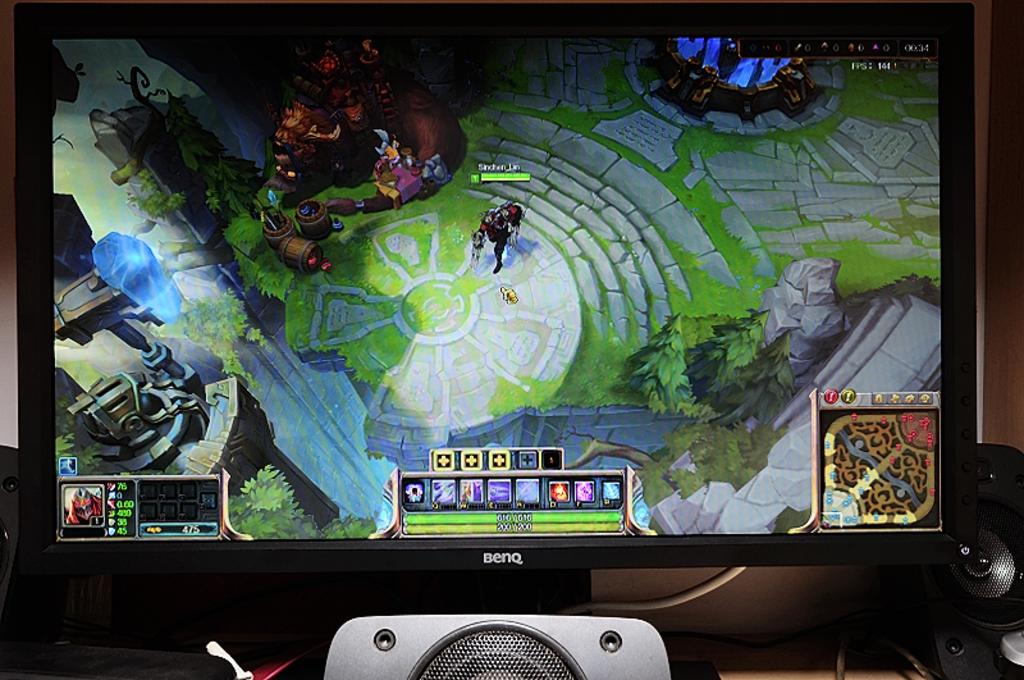Provide a one-sentence caption for the provided image. a screen of a video game, the characters user name has an underscore. 